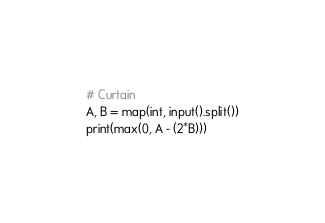<code> <loc_0><loc_0><loc_500><loc_500><_Python_># Curtain
A, B = map(int, input().split())
print(max(0, A - (2*B)))
</code> 